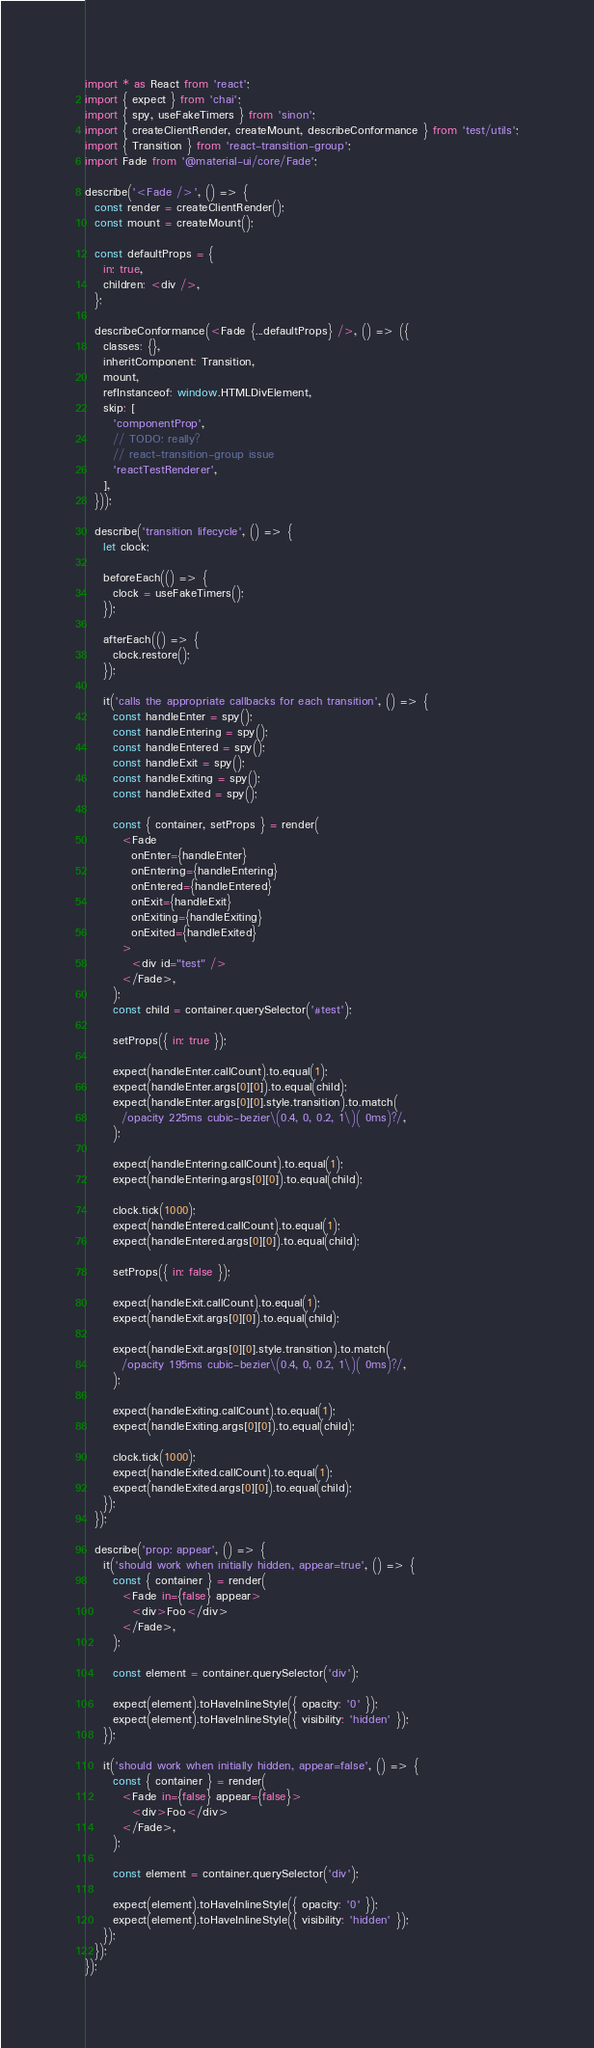<code> <loc_0><loc_0><loc_500><loc_500><_JavaScript_>import * as React from 'react';
import { expect } from 'chai';
import { spy, useFakeTimers } from 'sinon';
import { createClientRender, createMount, describeConformance } from 'test/utils';
import { Transition } from 'react-transition-group';
import Fade from '@material-ui/core/Fade';

describe('<Fade />', () => {
  const render = createClientRender();
  const mount = createMount();

  const defaultProps = {
    in: true,
    children: <div />,
  };

  describeConformance(<Fade {...defaultProps} />, () => ({
    classes: {},
    inheritComponent: Transition,
    mount,
    refInstanceof: window.HTMLDivElement,
    skip: [
      'componentProp',
      // TODO: really?
      // react-transition-group issue
      'reactTestRenderer',
    ],
  }));

  describe('transition lifecycle', () => {
    let clock;

    beforeEach(() => {
      clock = useFakeTimers();
    });

    afterEach(() => {
      clock.restore();
    });

    it('calls the appropriate callbacks for each transition', () => {
      const handleEnter = spy();
      const handleEntering = spy();
      const handleEntered = spy();
      const handleExit = spy();
      const handleExiting = spy();
      const handleExited = spy();

      const { container, setProps } = render(
        <Fade
          onEnter={handleEnter}
          onEntering={handleEntering}
          onEntered={handleEntered}
          onExit={handleExit}
          onExiting={handleExiting}
          onExited={handleExited}
        >
          <div id="test" />
        </Fade>,
      );
      const child = container.querySelector('#test');

      setProps({ in: true });

      expect(handleEnter.callCount).to.equal(1);
      expect(handleEnter.args[0][0]).to.equal(child);
      expect(handleEnter.args[0][0].style.transition).to.match(
        /opacity 225ms cubic-bezier\(0.4, 0, 0.2, 1\)( 0ms)?/,
      );

      expect(handleEntering.callCount).to.equal(1);
      expect(handleEntering.args[0][0]).to.equal(child);

      clock.tick(1000);
      expect(handleEntered.callCount).to.equal(1);
      expect(handleEntered.args[0][0]).to.equal(child);

      setProps({ in: false });

      expect(handleExit.callCount).to.equal(1);
      expect(handleExit.args[0][0]).to.equal(child);

      expect(handleExit.args[0][0].style.transition).to.match(
        /opacity 195ms cubic-bezier\(0.4, 0, 0.2, 1\)( 0ms)?/,
      );

      expect(handleExiting.callCount).to.equal(1);
      expect(handleExiting.args[0][0]).to.equal(child);

      clock.tick(1000);
      expect(handleExited.callCount).to.equal(1);
      expect(handleExited.args[0][0]).to.equal(child);
    });
  });

  describe('prop: appear', () => {
    it('should work when initially hidden, appear=true', () => {
      const { container } = render(
        <Fade in={false} appear>
          <div>Foo</div>
        </Fade>,
      );

      const element = container.querySelector('div');

      expect(element).toHaveInlineStyle({ opacity: '0' });
      expect(element).toHaveInlineStyle({ visibility: 'hidden' });
    });

    it('should work when initially hidden, appear=false', () => {
      const { container } = render(
        <Fade in={false} appear={false}>
          <div>Foo</div>
        </Fade>,
      );

      const element = container.querySelector('div');

      expect(element).toHaveInlineStyle({ opacity: '0' });
      expect(element).toHaveInlineStyle({ visibility: 'hidden' });
    });
  });
});
</code> 